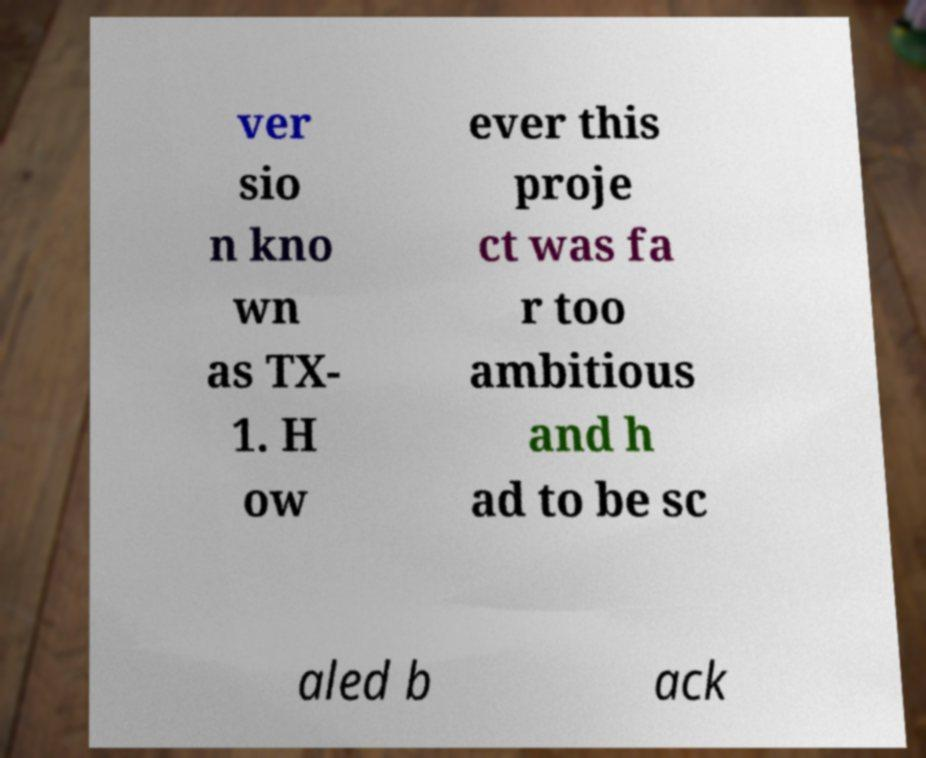Could you extract and type out the text from this image? ver sio n kno wn as TX- 1. H ow ever this proje ct was fa r too ambitious and h ad to be sc aled b ack 